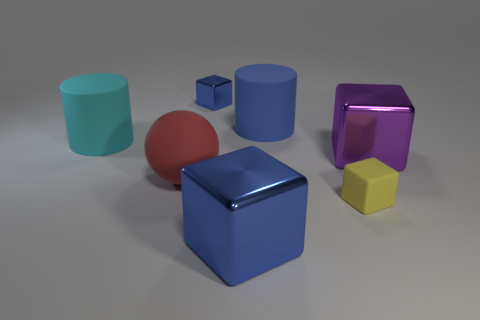Which objects seem closest to the viewer in the image? The objects closest to the viewer are the large blue cube and the red sphere. Positioned at the front of the composition, they dominate the foreground, while the other objects are arranged towards the middle ground or in the background, giving a sense of depth to the scene. 